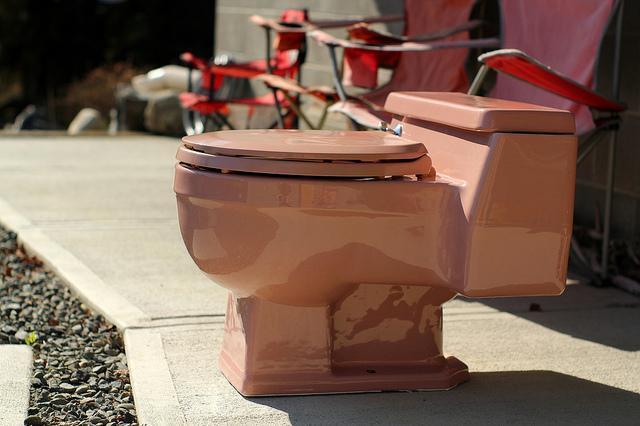How many chairs are there?
Give a very brief answer. 3. How many people are in white?
Give a very brief answer. 0. 